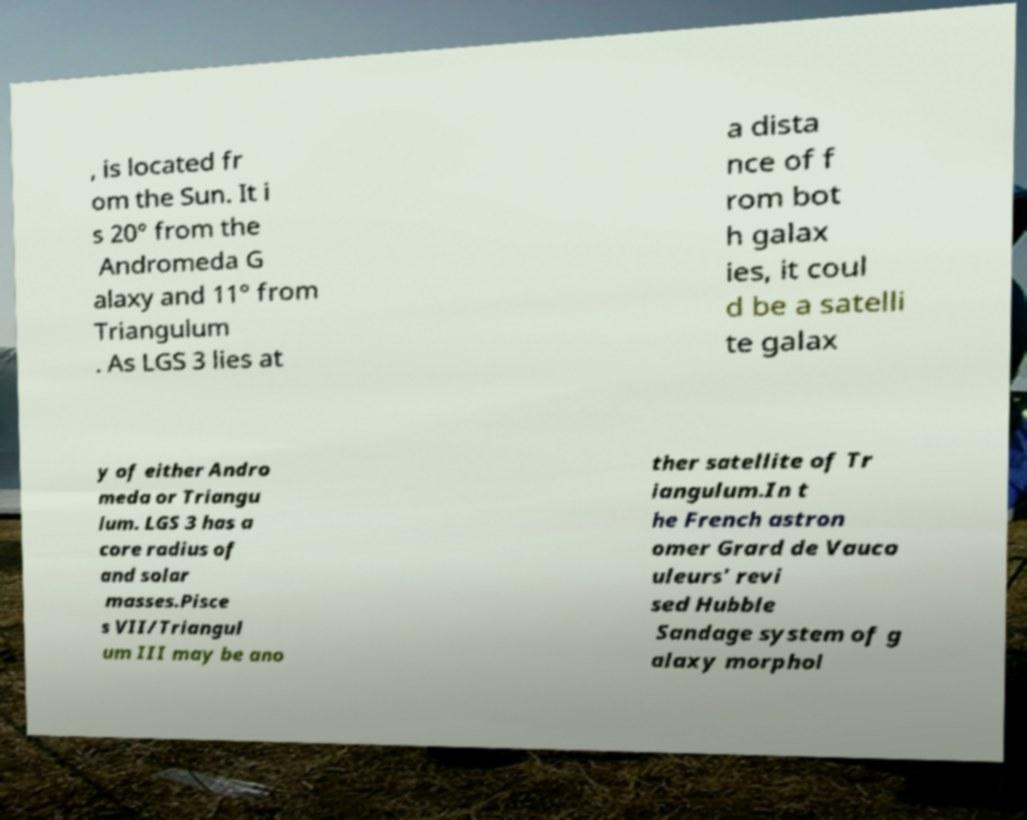Please identify and transcribe the text found in this image. , is located fr om the Sun. It i s 20° from the Andromeda G alaxy and 11° from Triangulum . As LGS 3 lies at a dista nce of f rom bot h galax ies, it coul d be a satelli te galax y of either Andro meda or Triangu lum. LGS 3 has a core radius of and solar masses.Pisce s VII/Triangul um III may be ano ther satellite of Tr iangulum.In t he French astron omer Grard de Vauco uleurs' revi sed Hubble Sandage system of g alaxy morphol 